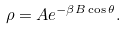Convert formula to latex. <formula><loc_0><loc_0><loc_500><loc_500>\rho = A e ^ { - \beta B \cos \theta } .</formula> 